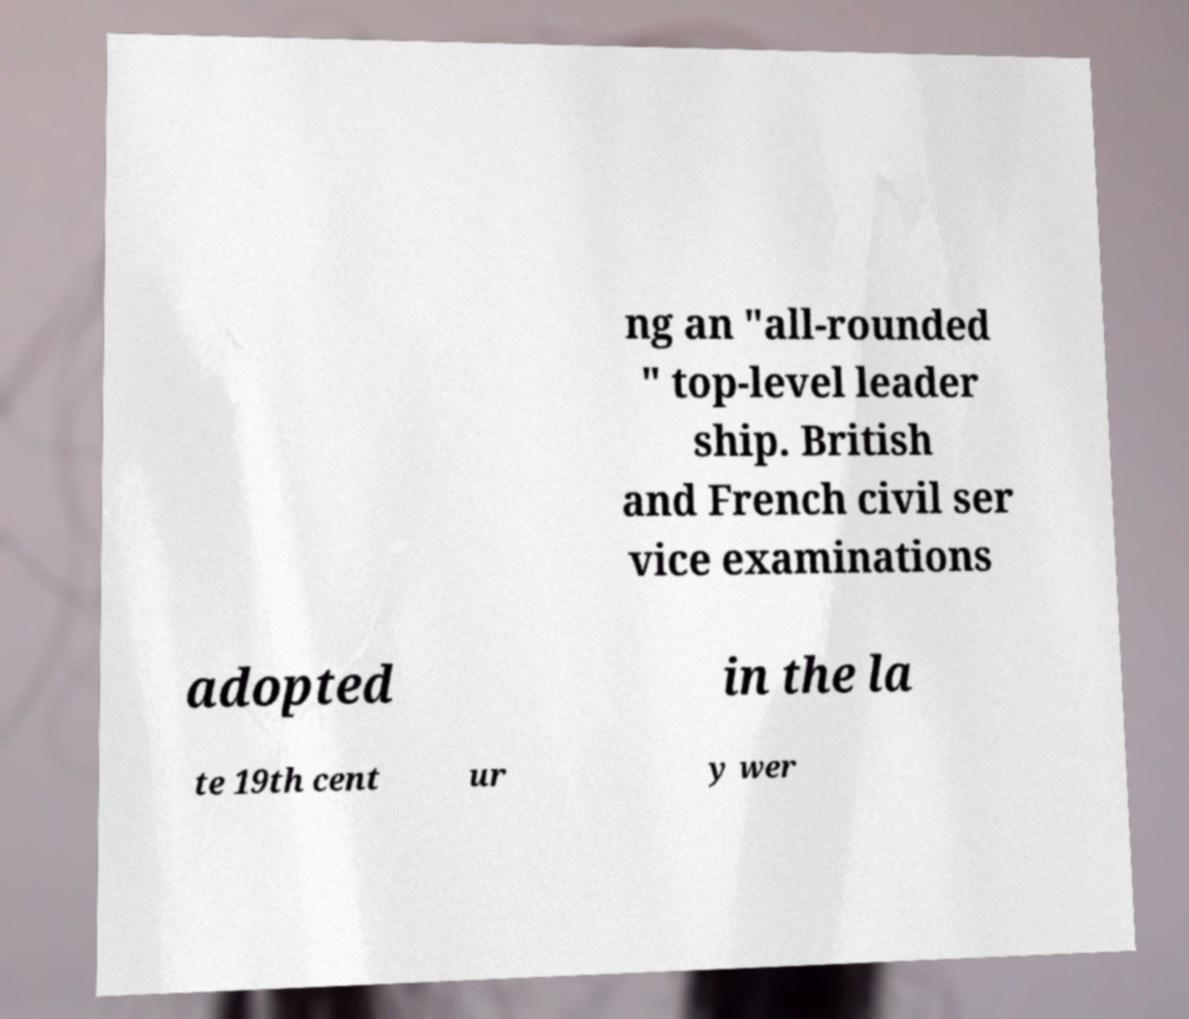For documentation purposes, I need the text within this image transcribed. Could you provide that? ng an "all-rounded " top-level leader ship. British and French civil ser vice examinations adopted in the la te 19th cent ur y wer 